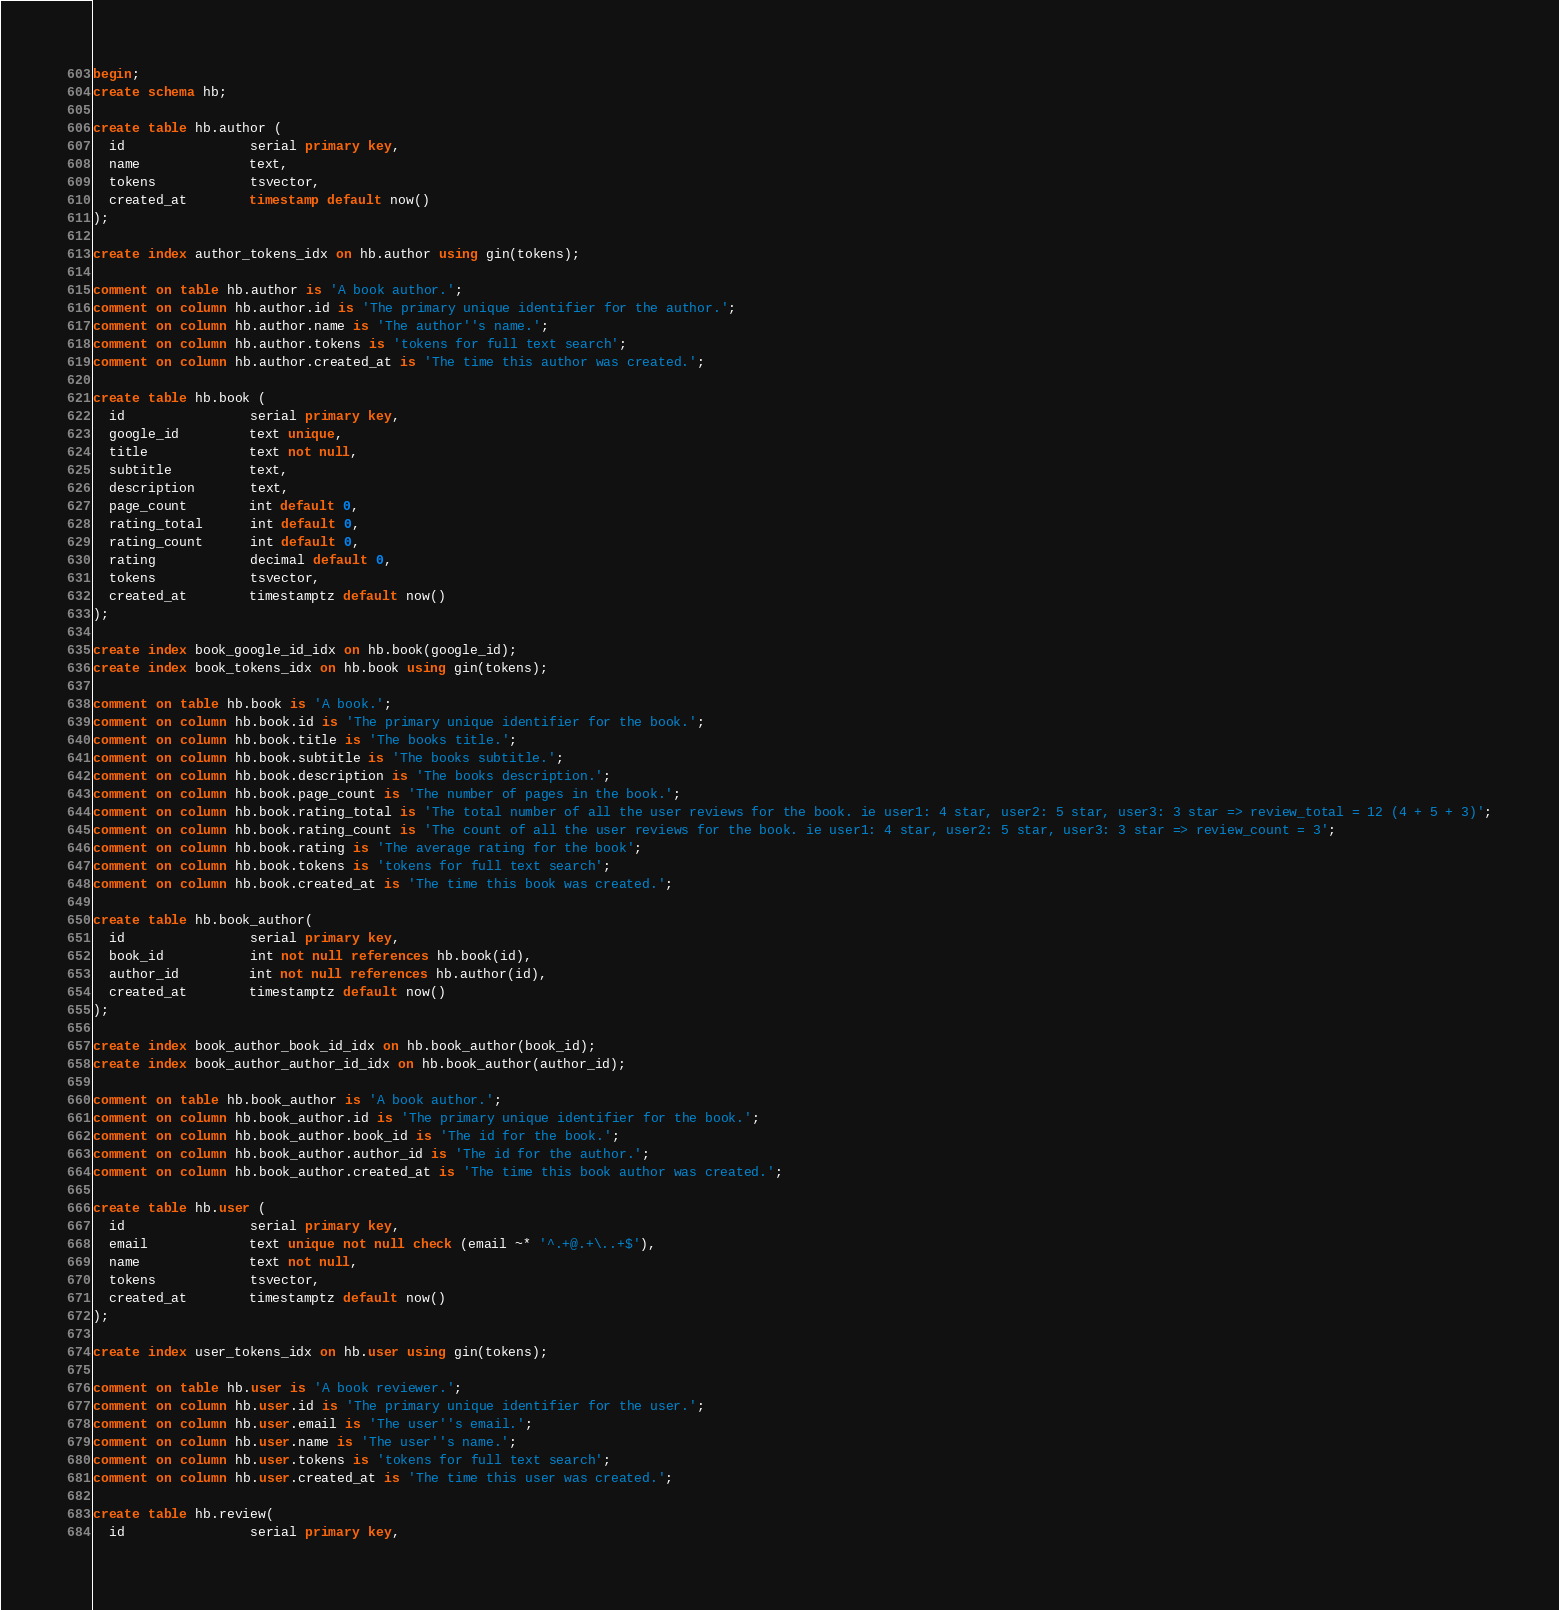Convert code to text. <code><loc_0><loc_0><loc_500><loc_500><_SQL_>begin;
create schema hb;

create table hb.author (
  id                serial primary key,
  name              text,
  tokens            tsvector,
  created_at        timestamp default now()
);

create index author_tokens_idx on hb.author using gin(tokens);

comment on table hb.author is 'A book author.';
comment on column hb.author.id is 'The primary unique identifier for the author.';
comment on column hb.author.name is 'The author''s name.';
comment on column hb.author.tokens is 'tokens for full text search';
comment on column hb.author.created_at is 'The time this author was created.';

create table hb.book (
  id                serial primary key,
  google_id         text unique,
  title             text not null,
  subtitle          text,
  description       text,
  page_count        int default 0,
  rating_total      int default 0,
  rating_count      int default 0,
  rating            decimal default 0,
  tokens            tsvector,
  created_at        timestamptz default now()
);

create index book_google_id_idx on hb.book(google_id);
create index book_tokens_idx on hb.book using gin(tokens);

comment on table hb.book is 'A book.';
comment on column hb.book.id is 'The primary unique identifier for the book.';
comment on column hb.book.title is 'The books title.';
comment on column hb.book.subtitle is 'The books subtitle.';
comment on column hb.book.description is 'The books description.';
comment on column hb.book.page_count is 'The number of pages in the book.';
comment on column hb.book.rating_total is 'The total number of all the user reviews for the book. ie user1: 4 star, user2: 5 star, user3: 3 star => review_total = 12 (4 + 5 + 3)';
comment on column hb.book.rating_count is 'The count of all the user reviews for the book. ie user1: 4 star, user2: 5 star, user3: 3 star => review_count = 3';
comment on column hb.book.rating is 'The average rating for the book';
comment on column hb.book.tokens is 'tokens for full text search';
comment on column hb.book.created_at is 'The time this book was created.';

create table hb.book_author(
  id                serial primary key,
  book_id           int not null references hb.book(id),
  author_id         int not null references hb.author(id),
  created_at        timestamptz default now()
);

create index book_author_book_id_idx on hb.book_author(book_id);
create index book_author_author_id_idx on hb.book_author(author_id);

comment on table hb.book_author is 'A book author.';
comment on column hb.book_author.id is 'The primary unique identifier for the book.';
comment on column hb.book_author.book_id is 'The id for the book.';
comment on column hb.book_author.author_id is 'The id for the author.';
comment on column hb.book_author.created_at is 'The time this book author was created.';

create table hb.user (
  id                serial primary key,
  email             text unique not null check (email ~* '^.+@.+\..+$'),
  name              text not null,
  tokens            tsvector,
  created_at        timestamptz default now()
);

create index user_tokens_idx on hb.user using gin(tokens);

comment on table hb.user is 'A book reviewer.';
comment on column hb.user.id is 'The primary unique identifier for the user.';
comment on column hb.user.email is 'The user''s email.';
comment on column hb.user.name is 'The user''s name.';
comment on column hb.user.tokens is 'tokens for full text search';
comment on column hb.user.created_at is 'The time this user was created.';

create table hb.review(
  id                serial primary key,</code> 